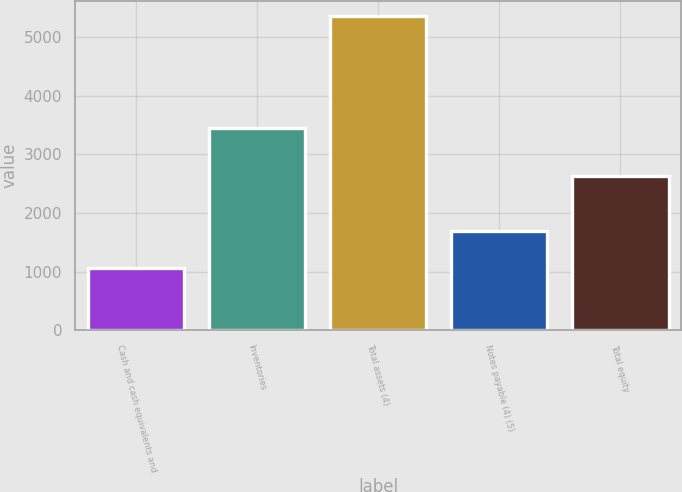Convert chart to OTSL. <chart><loc_0><loc_0><loc_500><loc_500><bar_chart><fcel>Cash and cash equivalents and<fcel>Inventories<fcel>Total assets (4)<fcel>Notes payable (4) (5)<fcel>Total equity<nl><fcel>1068.1<fcel>3449.7<fcel>5350.6<fcel>1696.8<fcel>2623.5<nl></chart> 